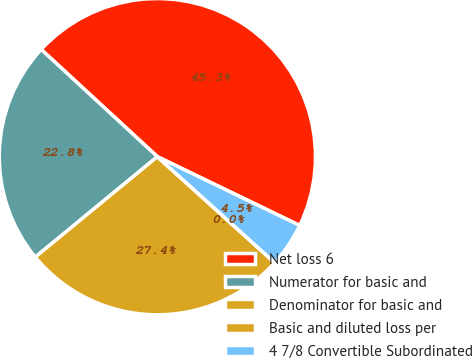Convert chart to OTSL. <chart><loc_0><loc_0><loc_500><loc_500><pie_chart><fcel>Net loss 6<fcel>Numerator for basic and<fcel>Denominator for basic and<fcel>Basic and diluted loss per<fcel>4 7/8 Convertible Subordinated<nl><fcel>45.3%<fcel>22.82%<fcel>27.35%<fcel>0.0%<fcel>4.53%<nl></chart> 